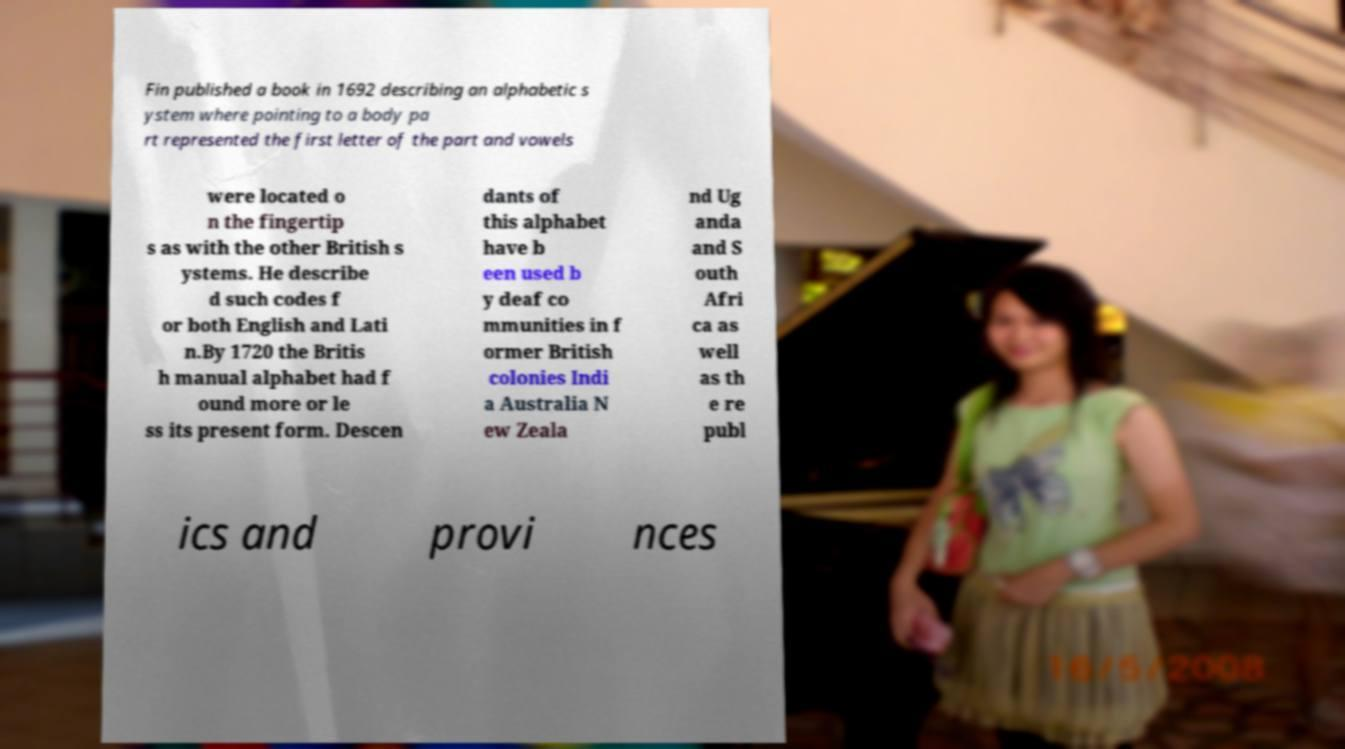Please identify and transcribe the text found in this image. Fin published a book in 1692 describing an alphabetic s ystem where pointing to a body pa rt represented the first letter of the part and vowels were located o n the fingertip s as with the other British s ystems. He describe d such codes f or both English and Lati n.By 1720 the Britis h manual alphabet had f ound more or le ss its present form. Descen dants of this alphabet have b een used b y deaf co mmunities in f ormer British colonies Indi a Australia N ew Zeala nd Ug anda and S outh Afri ca as well as th e re publ ics and provi nces 